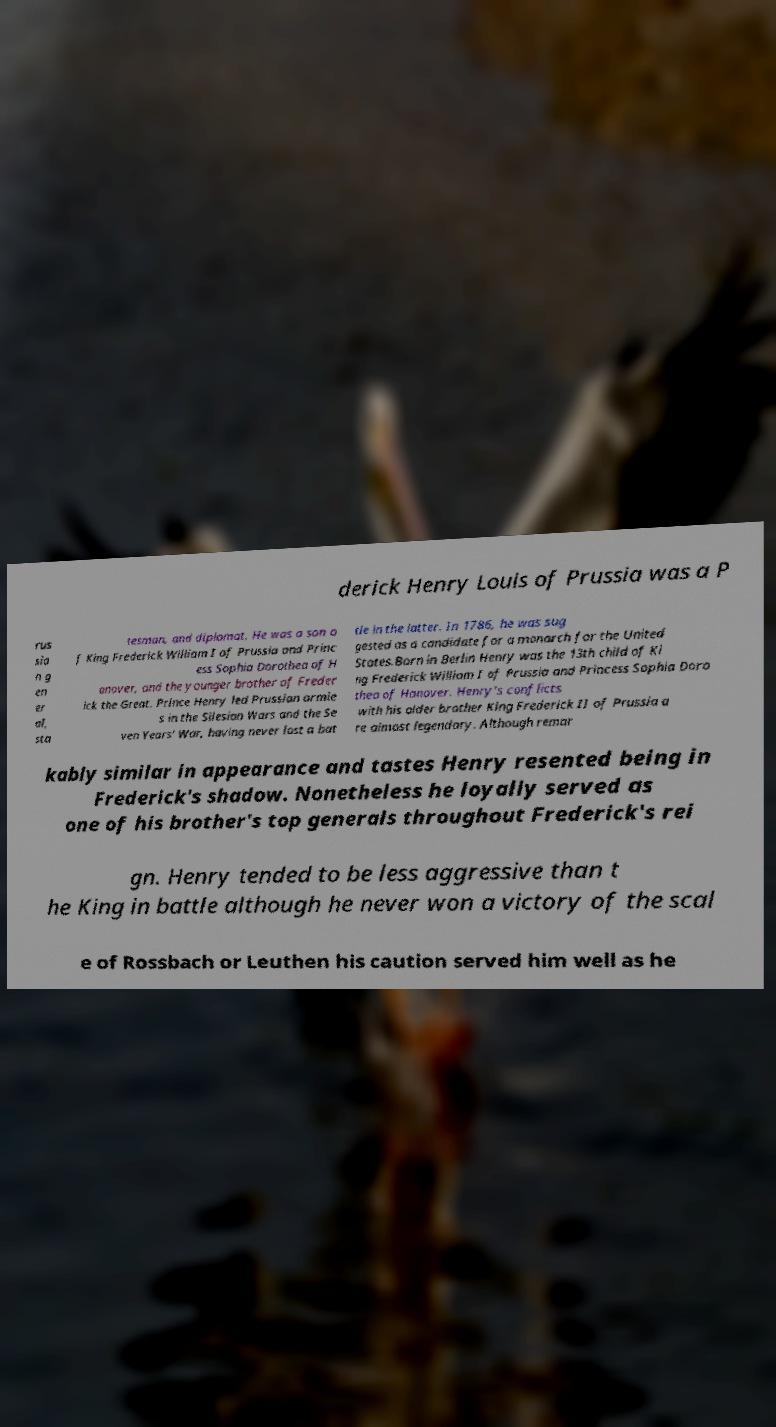There's text embedded in this image that I need extracted. Can you transcribe it verbatim? derick Henry Louis of Prussia was a P rus sia n g en er al, sta tesman, and diplomat. He was a son o f King Frederick William I of Prussia and Princ ess Sophia Dorothea of H anover, and the younger brother of Freder ick the Great. Prince Henry led Prussian armie s in the Silesian Wars and the Se ven Years' War, having never lost a bat tle in the latter. In 1786, he was sug gested as a candidate for a monarch for the United States.Born in Berlin Henry was the 13th child of Ki ng Frederick William I of Prussia and Princess Sophia Doro thea of Hanover. Henry's conflicts with his older brother King Frederick II of Prussia a re almost legendary. Although remar kably similar in appearance and tastes Henry resented being in Frederick's shadow. Nonetheless he loyally served as one of his brother's top generals throughout Frederick's rei gn. Henry tended to be less aggressive than t he King in battle although he never won a victory of the scal e of Rossbach or Leuthen his caution served him well as he 